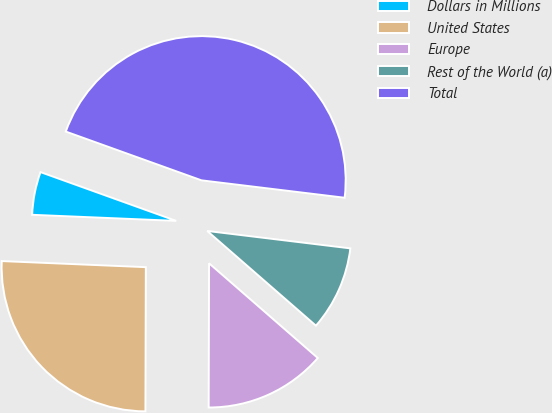Convert chart to OTSL. <chart><loc_0><loc_0><loc_500><loc_500><pie_chart><fcel>Dollars in Millions<fcel>United States<fcel>Europe<fcel>Rest of the World (a)<fcel>Total<nl><fcel>4.82%<fcel>25.63%<fcel>13.64%<fcel>9.48%<fcel>46.44%<nl></chart> 